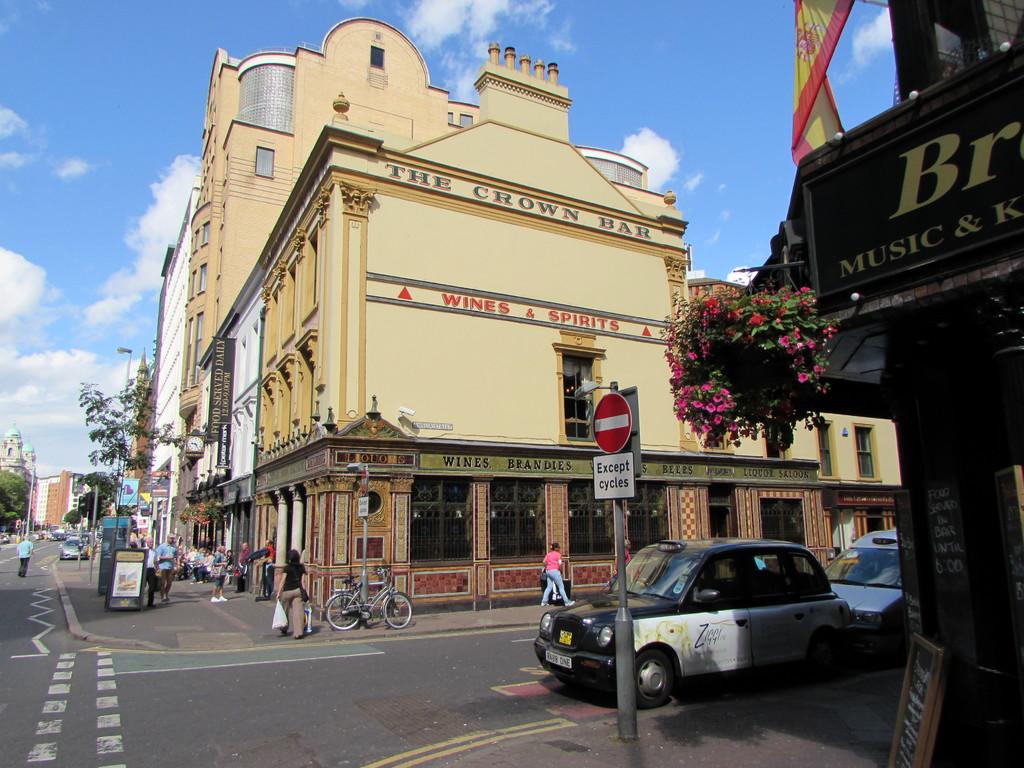What does the road sign say except for?
Provide a short and direct response. Cycles. 